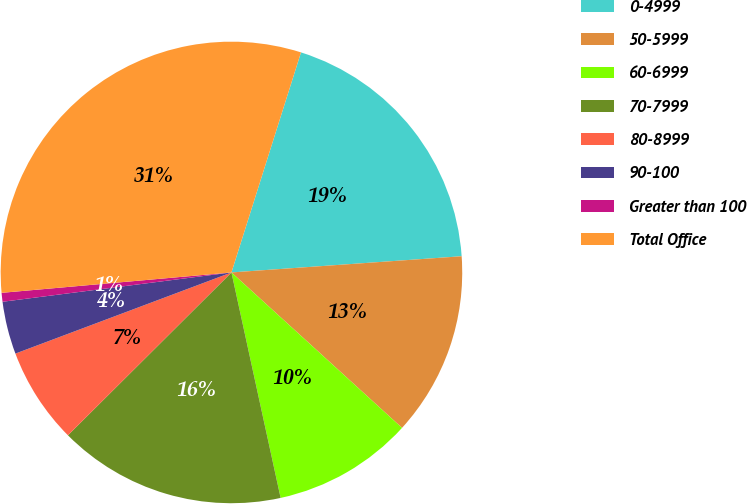Convert chart. <chart><loc_0><loc_0><loc_500><loc_500><pie_chart><fcel>0-4999<fcel>50-5999<fcel>60-6999<fcel>70-7999<fcel>80-8999<fcel>90-100<fcel>Greater than 100<fcel>Total Office<nl><fcel>19.01%<fcel>12.88%<fcel>9.82%<fcel>15.95%<fcel>6.75%<fcel>3.69%<fcel>0.62%<fcel>31.28%<nl></chart> 